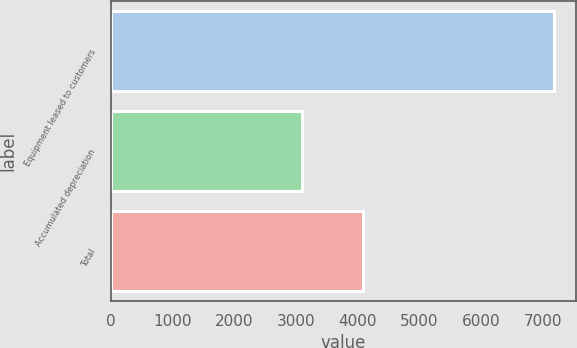Convert chart to OTSL. <chart><loc_0><loc_0><loc_500><loc_500><bar_chart><fcel>Equipment leased to customers<fcel>Accumulated depreciation<fcel>Total<nl><fcel>7185<fcel>3101<fcel>4084<nl></chart> 